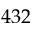<formula> <loc_0><loc_0><loc_500><loc_500>4 3 2</formula> 